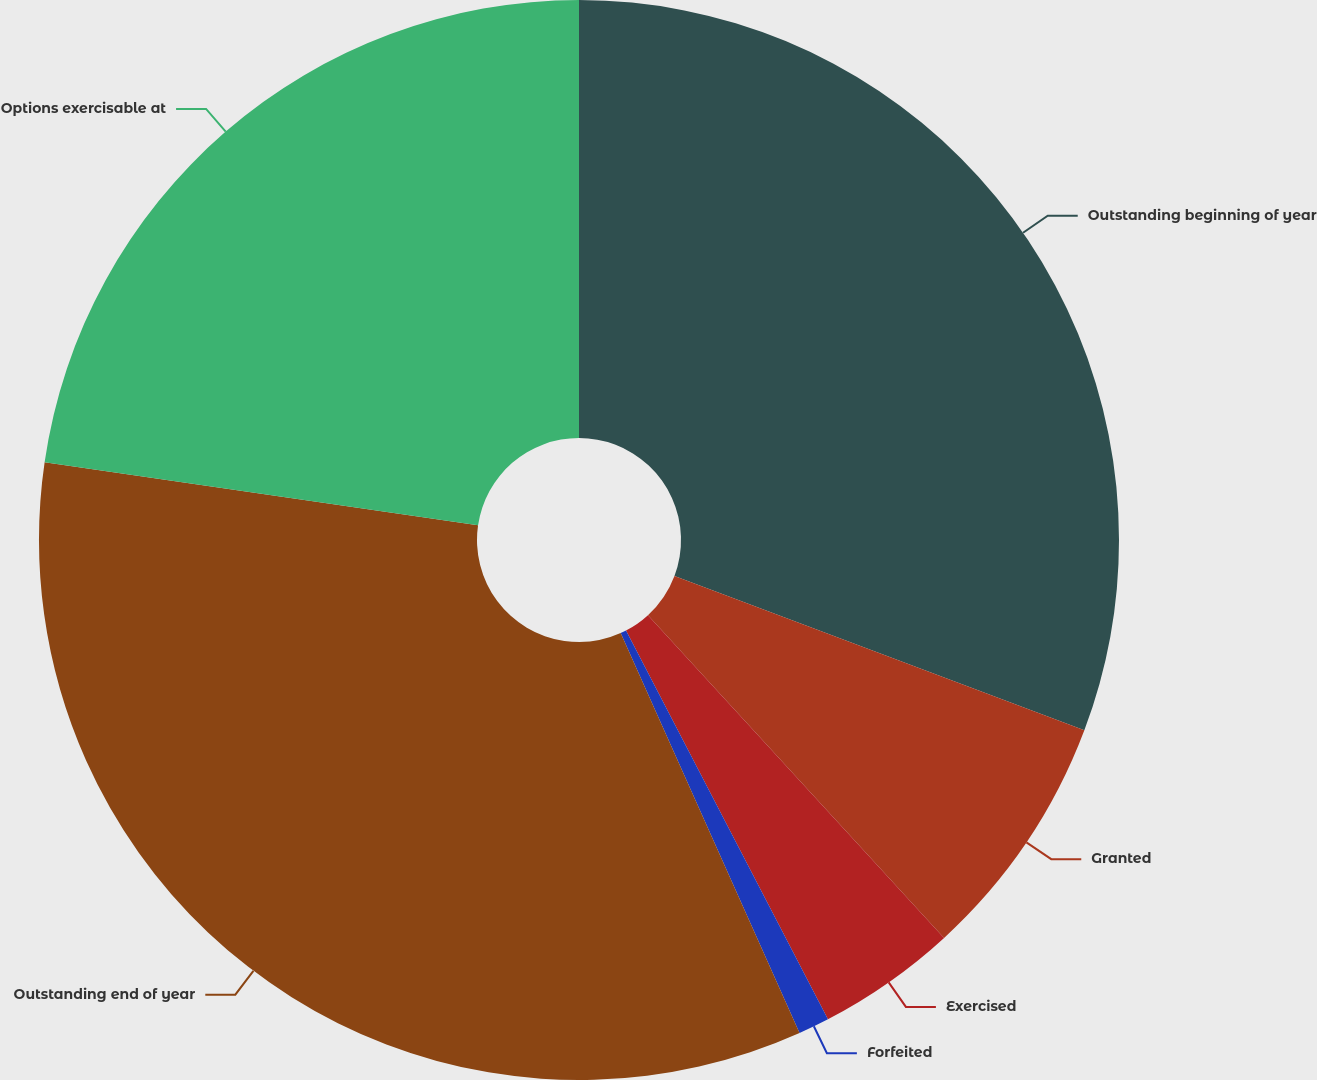Convert chart to OTSL. <chart><loc_0><loc_0><loc_500><loc_500><pie_chart><fcel>Outstanding beginning of year<fcel>Granted<fcel>Exercised<fcel>Forfeited<fcel>Outstanding end of year<fcel>Options exercisable at<nl><fcel>30.73%<fcel>7.45%<fcel>4.19%<fcel>0.93%<fcel>33.99%<fcel>22.7%<nl></chart> 